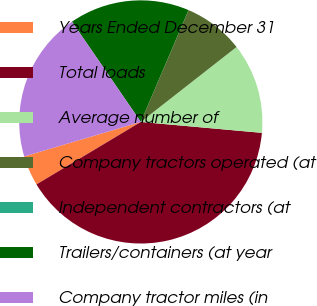Convert chart. <chart><loc_0><loc_0><loc_500><loc_500><pie_chart><fcel>Years Ended December 31<fcel>Total loads<fcel>Average number of<fcel>Company tractors operated (at<fcel>Independent contractors (at<fcel>Trailers/containers (at year<fcel>Company tractor miles (in<nl><fcel>4.01%<fcel>39.98%<fcel>12.0%<fcel>8.0%<fcel>0.01%<fcel>16.0%<fcel>20.0%<nl></chart> 